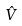Convert formula to latex. <formula><loc_0><loc_0><loc_500><loc_500>\hat { V }</formula> 